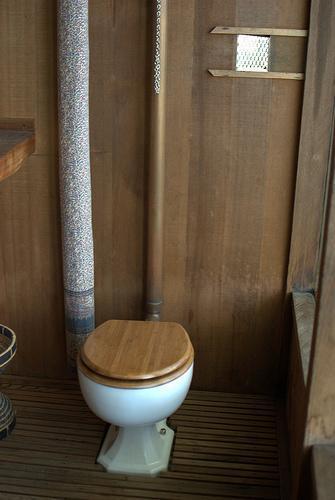How many toilets are there?
Give a very brief answer. 1. How many pipes are there?
Give a very brief answer. 2. 